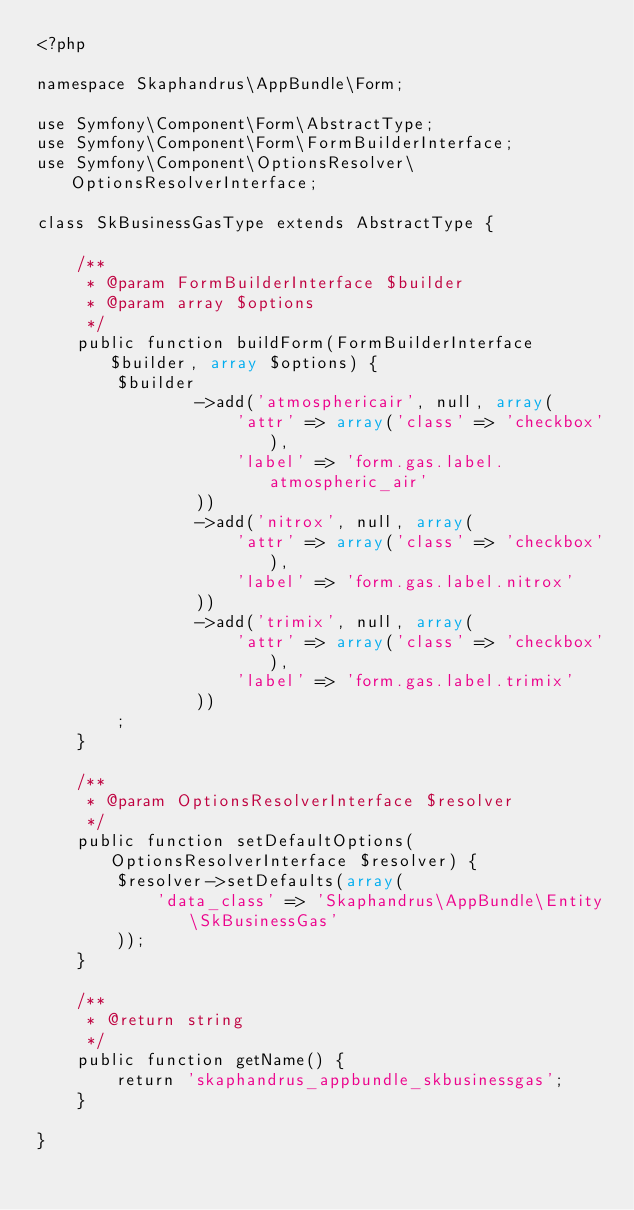Convert code to text. <code><loc_0><loc_0><loc_500><loc_500><_PHP_><?php

namespace Skaphandrus\AppBundle\Form;

use Symfony\Component\Form\AbstractType;
use Symfony\Component\Form\FormBuilderInterface;
use Symfony\Component\OptionsResolver\OptionsResolverInterface;

class SkBusinessGasType extends AbstractType {

    /**
     * @param FormBuilderInterface $builder
     * @param array $options
     */
    public function buildForm(FormBuilderInterface $builder, array $options) {
        $builder
                ->add('atmosphericair', null, array(
                    'attr' => array('class' => 'checkbox'),
                    'label' => 'form.gas.label.atmospheric_air'
                ))
                ->add('nitrox', null, array(
                    'attr' => array('class' => 'checkbox'),
                    'label' => 'form.gas.label.nitrox'
                ))
                ->add('trimix', null, array(
                    'attr' => array('class' => 'checkbox'),
                    'label' => 'form.gas.label.trimix'
                ))
        ;
    }

    /**
     * @param OptionsResolverInterface $resolver
     */
    public function setDefaultOptions(OptionsResolverInterface $resolver) {
        $resolver->setDefaults(array(
            'data_class' => 'Skaphandrus\AppBundle\Entity\SkBusinessGas'
        ));
    }

    /**
     * @return string
     */
    public function getName() {
        return 'skaphandrus_appbundle_skbusinessgas';
    }

}
</code> 